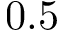Convert formula to latex. <formula><loc_0><loc_0><loc_500><loc_500>0 . 5</formula> 